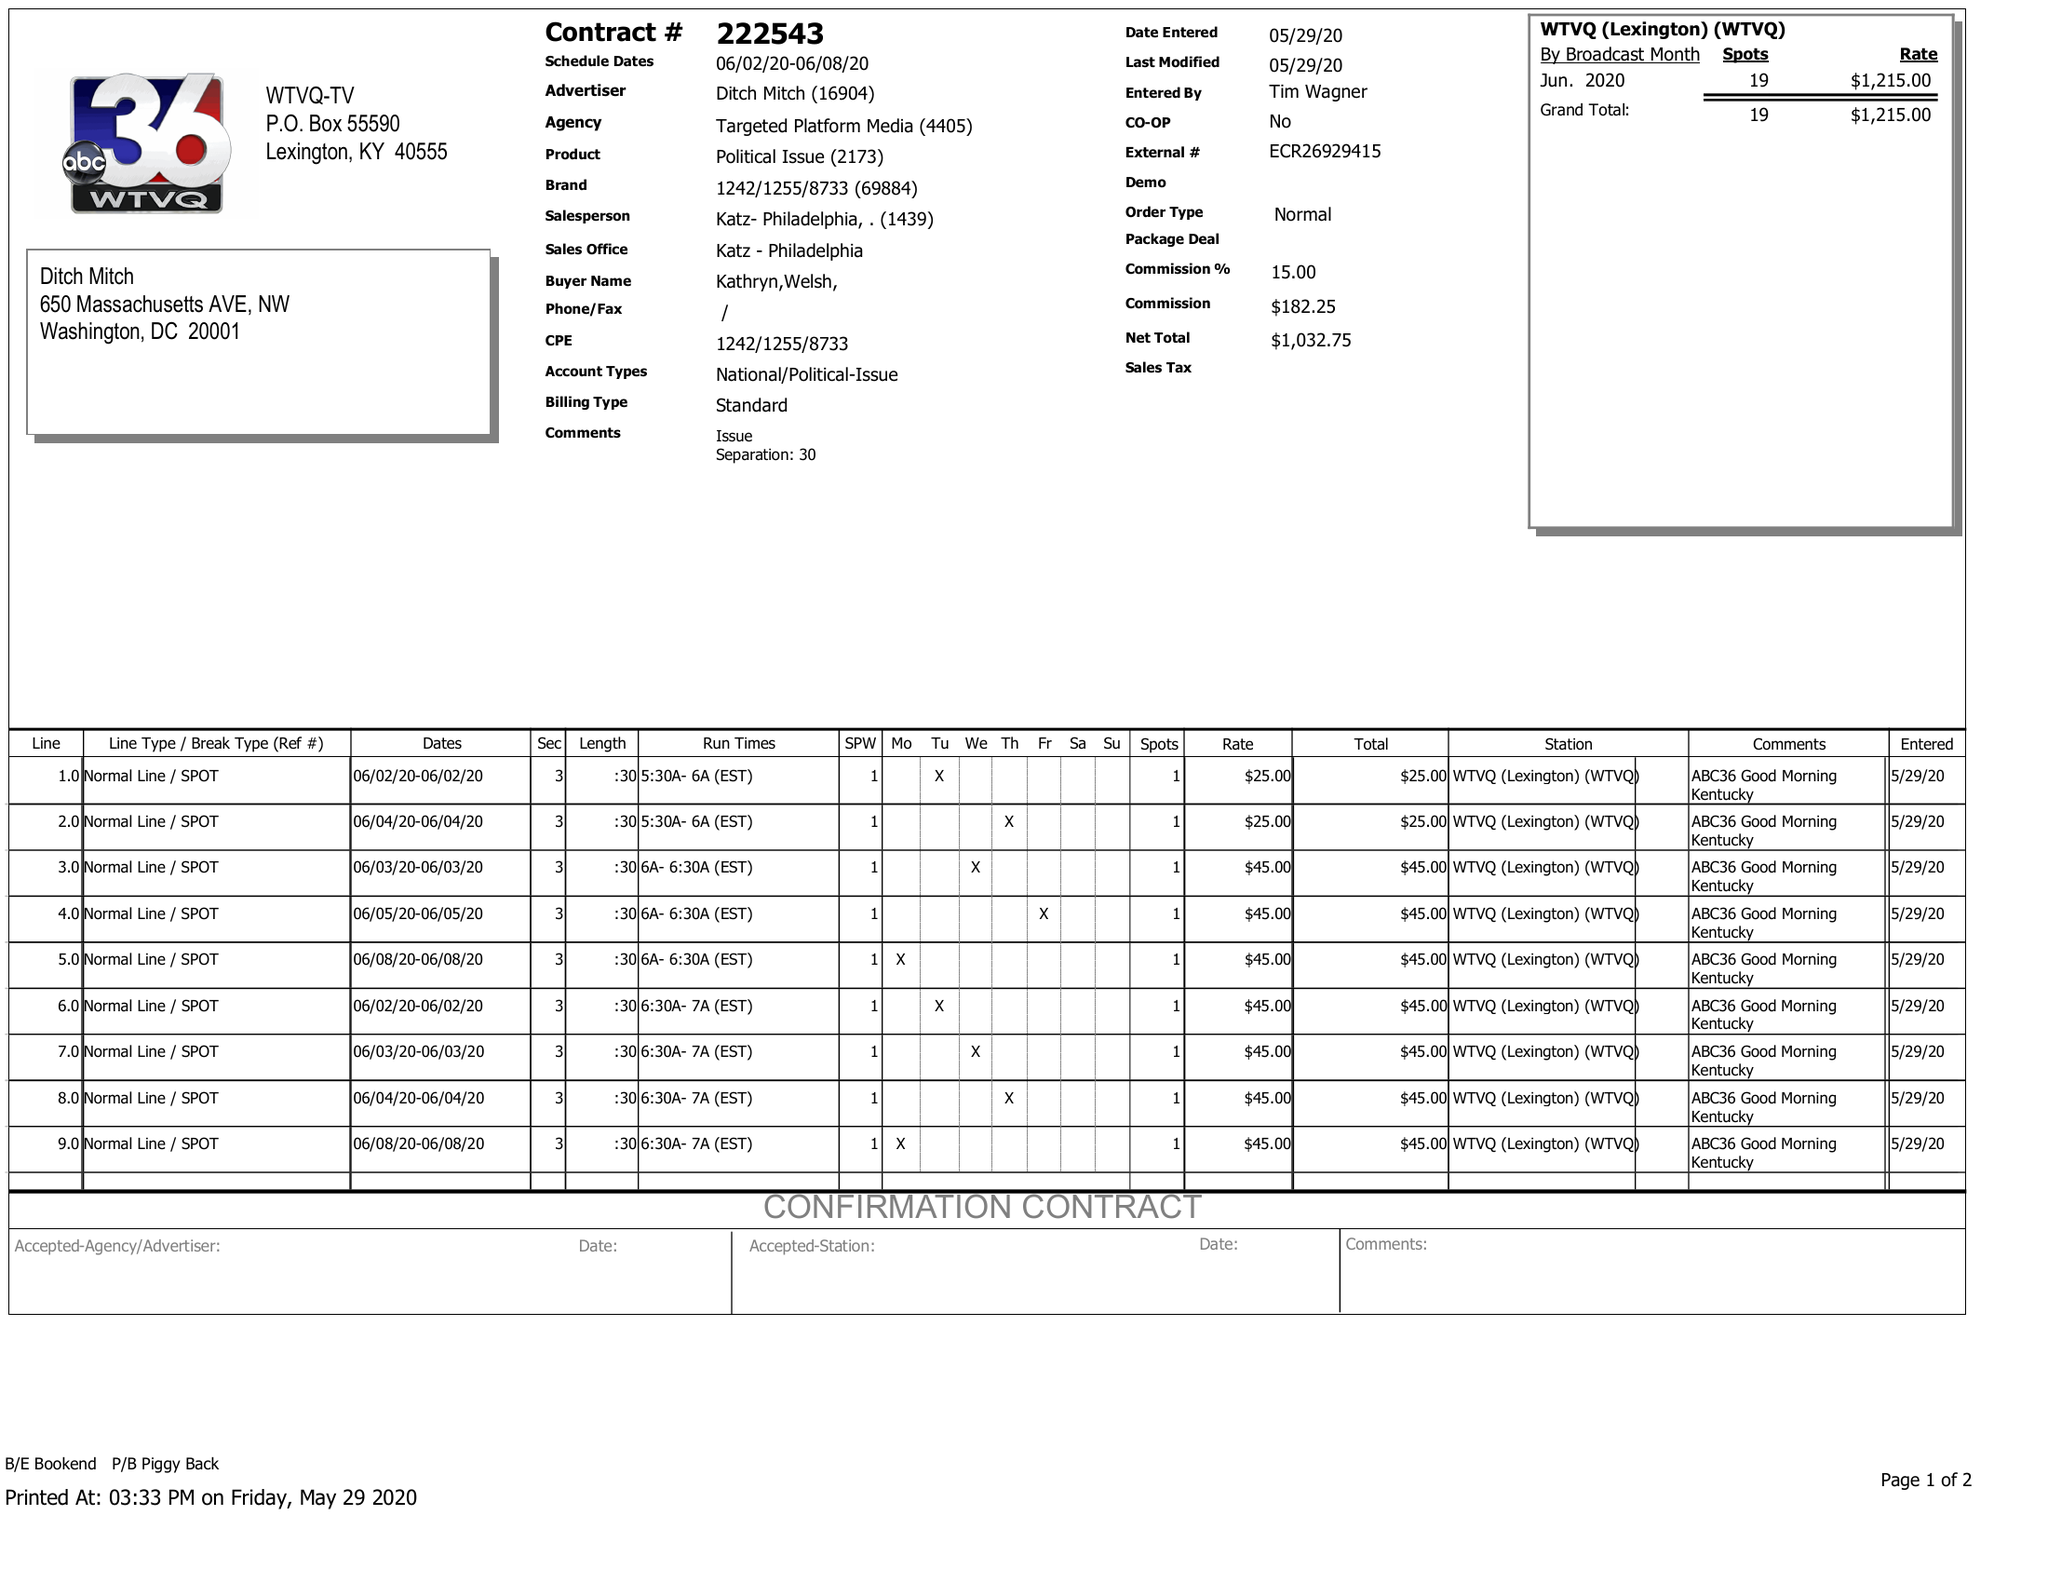What is the value for the flight_from?
Answer the question using a single word or phrase. 06/02/20 